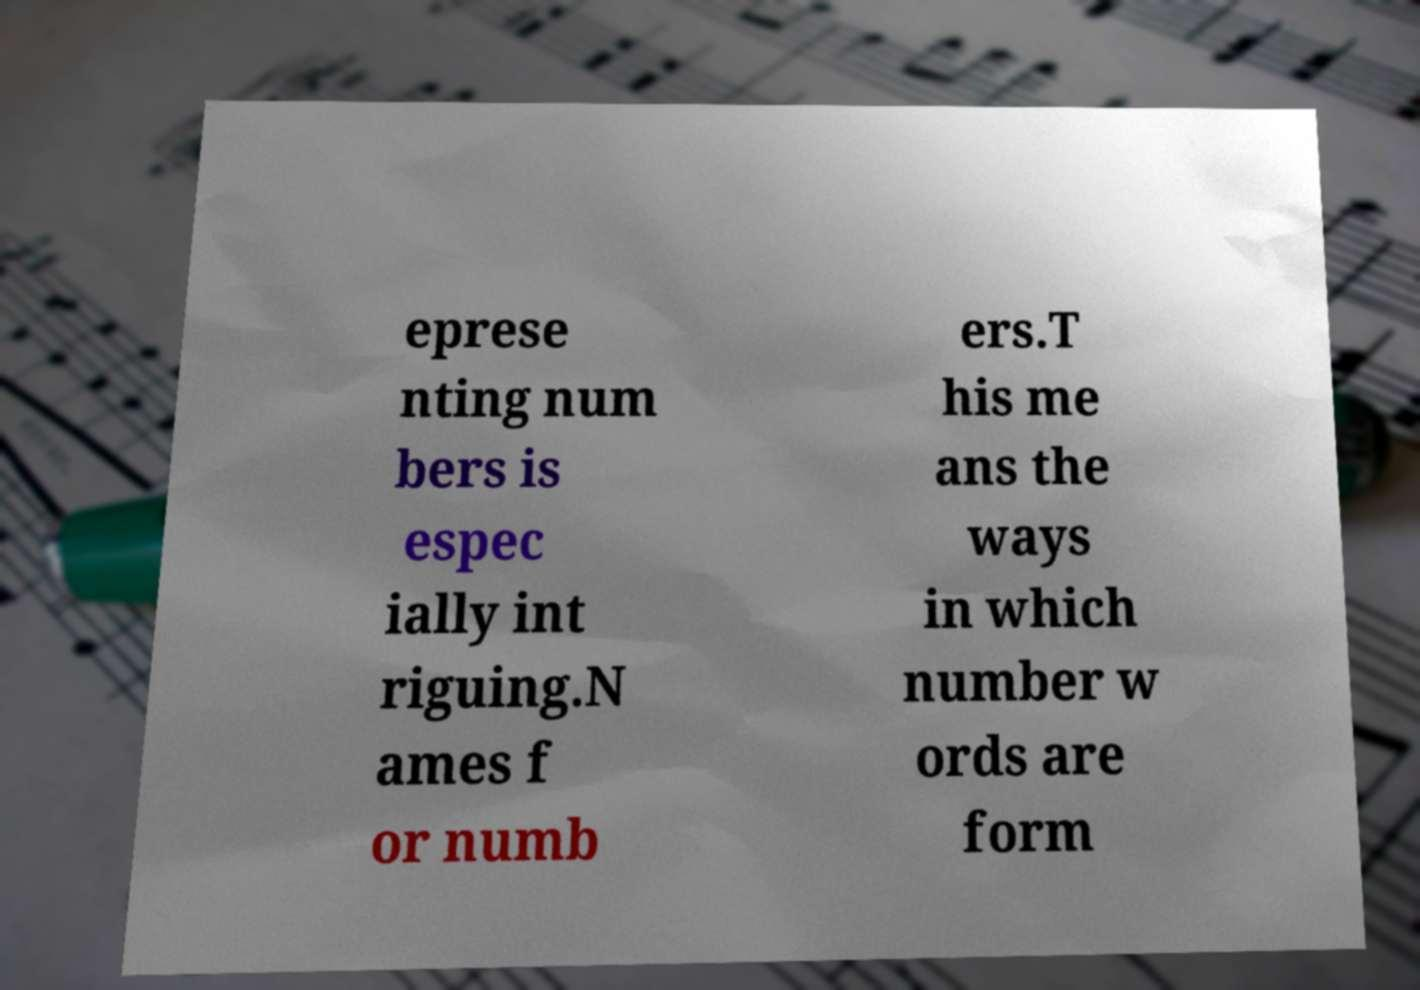Could you assist in decoding the text presented in this image and type it out clearly? eprese nting num bers is espec ially int riguing.N ames f or numb ers.T his me ans the ways in which number w ords are form 